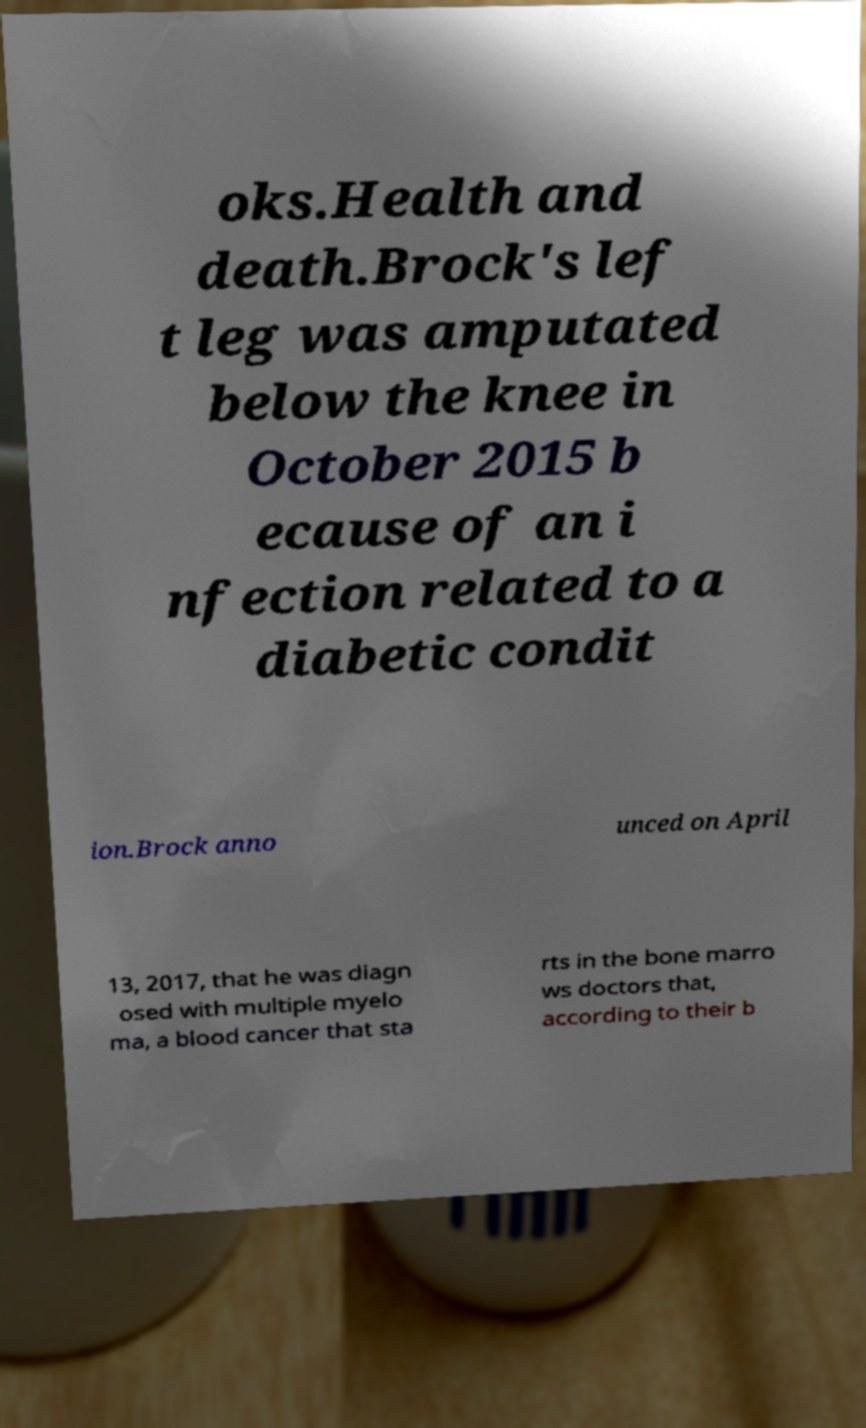There's text embedded in this image that I need extracted. Can you transcribe it verbatim? oks.Health and death.Brock's lef t leg was amputated below the knee in October 2015 b ecause of an i nfection related to a diabetic condit ion.Brock anno unced on April 13, 2017, that he was diagn osed with multiple myelo ma, a blood cancer that sta rts in the bone marro ws doctors that, according to their b 